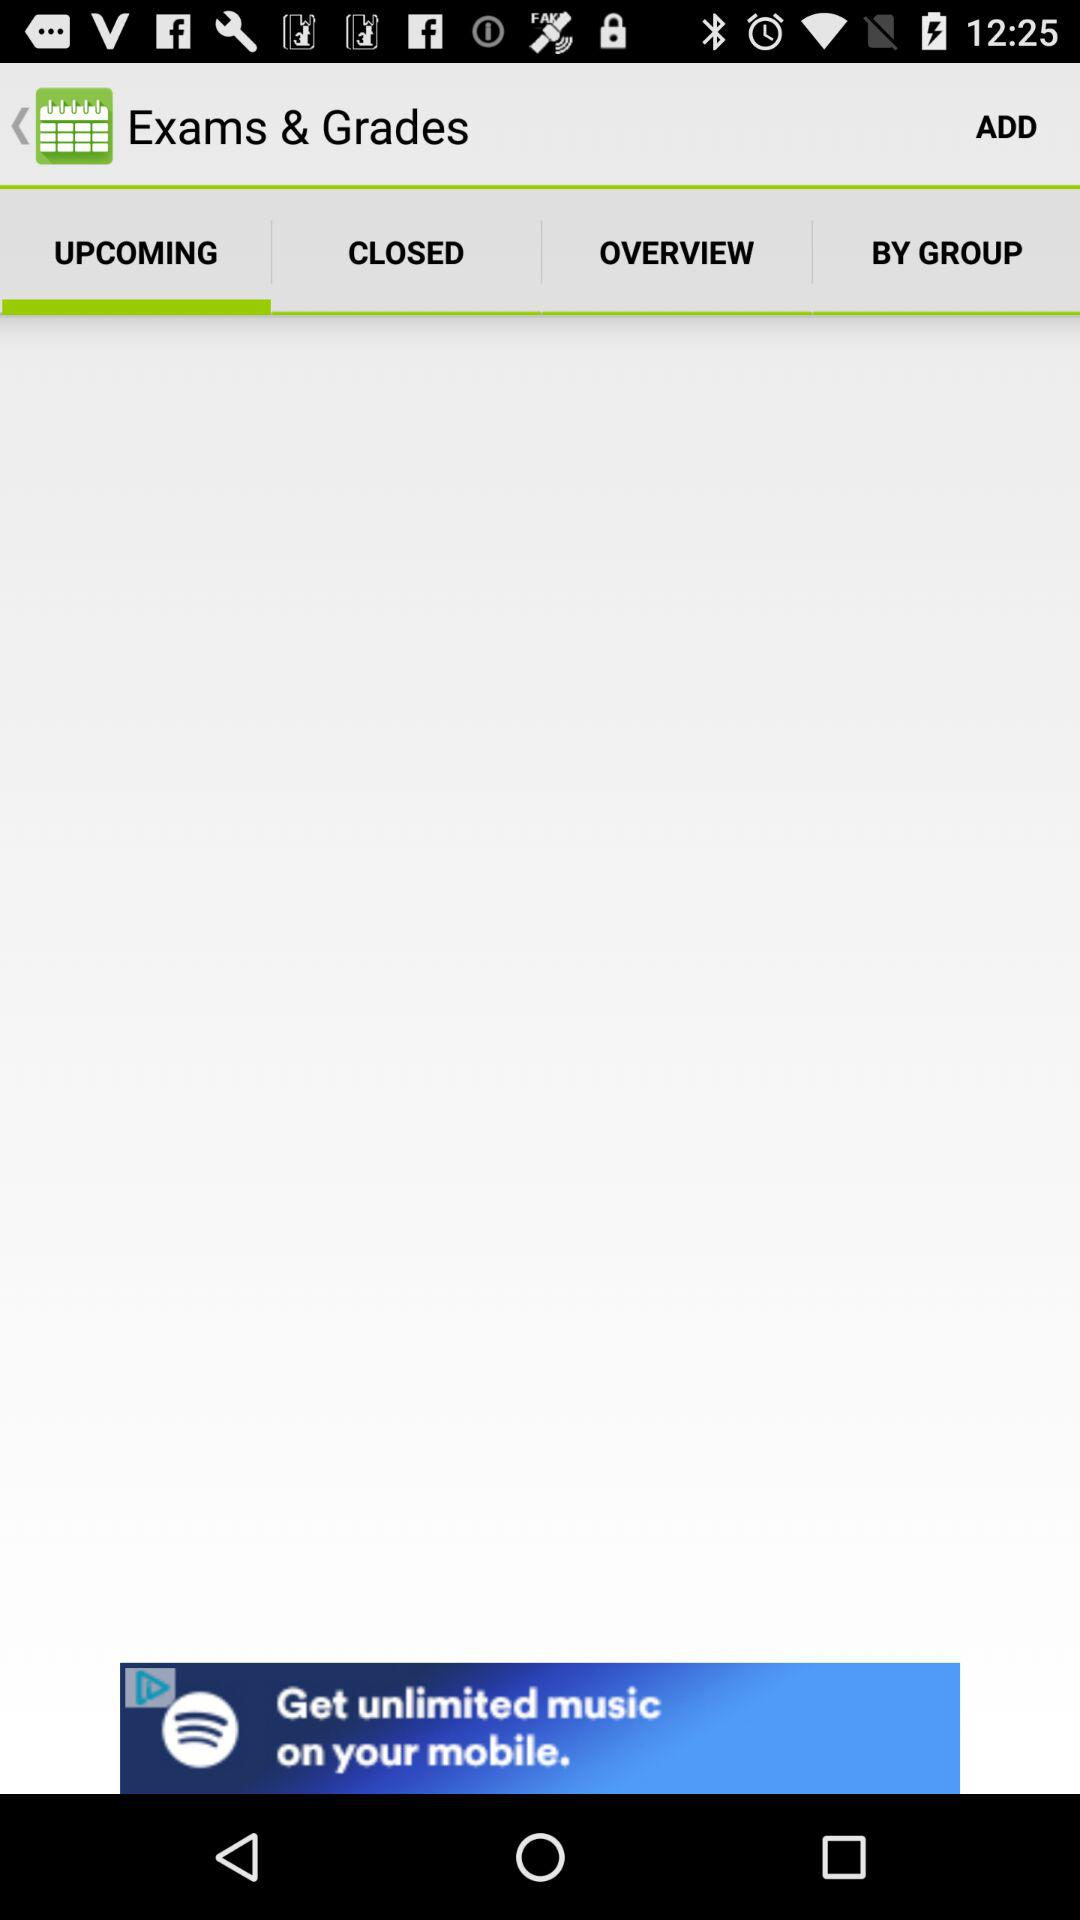Which tab is selected?
Answer the question using a single word or phrase. The selected tab is Upcoming 